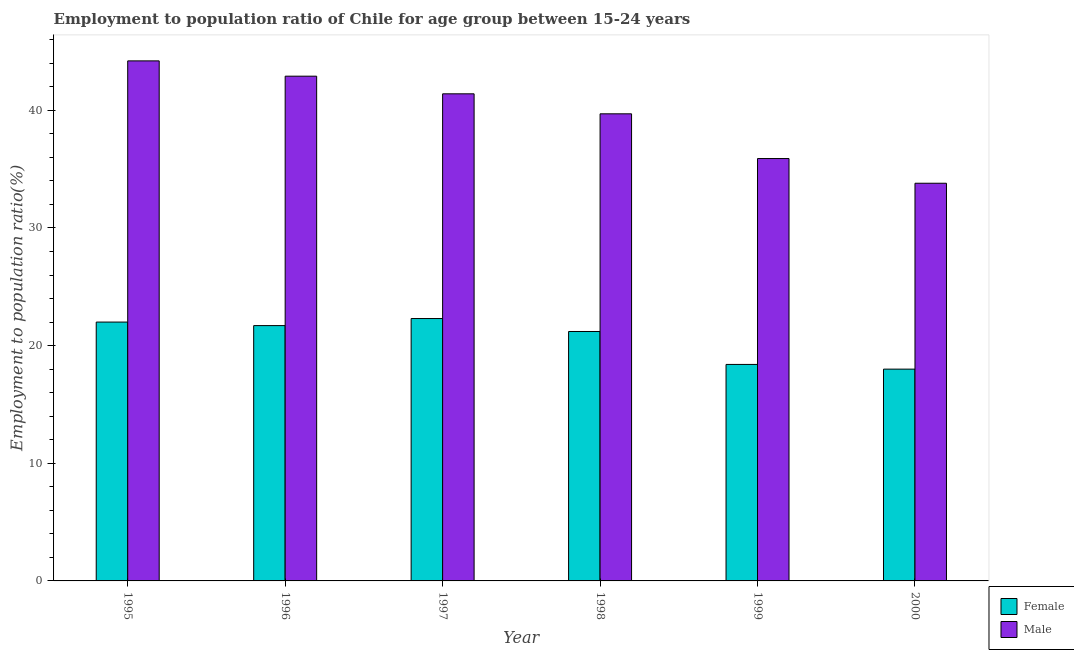How many groups of bars are there?
Provide a succinct answer. 6. How many bars are there on the 3rd tick from the right?
Provide a short and direct response. 2. What is the label of the 6th group of bars from the left?
Your answer should be very brief. 2000. In how many cases, is the number of bars for a given year not equal to the number of legend labels?
Offer a very short reply. 0. What is the employment to population ratio(male) in 1998?
Offer a terse response. 39.7. Across all years, what is the maximum employment to population ratio(female)?
Offer a terse response. 22.3. Across all years, what is the minimum employment to population ratio(male)?
Make the answer very short. 33.8. In which year was the employment to population ratio(female) maximum?
Your answer should be compact. 1997. What is the total employment to population ratio(female) in the graph?
Make the answer very short. 123.6. What is the difference between the employment to population ratio(male) in 1995 and that in 1998?
Give a very brief answer. 4.5. What is the difference between the employment to population ratio(female) in 1995 and the employment to population ratio(male) in 1996?
Ensure brevity in your answer.  0.3. What is the average employment to population ratio(male) per year?
Your answer should be compact. 39.65. What is the ratio of the employment to population ratio(male) in 1995 to that in 1996?
Your response must be concise. 1.03. Is the employment to population ratio(female) in 1996 less than that in 1998?
Offer a very short reply. No. Is the difference between the employment to population ratio(female) in 1995 and 1998 greater than the difference between the employment to population ratio(male) in 1995 and 1998?
Keep it short and to the point. No. What is the difference between the highest and the second highest employment to population ratio(female)?
Provide a short and direct response. 0.3. What is the difference between the highest and the lowest employment to population ratio(male)?
Your response must be concise. 10.4. In how many years, is the employment to population ratio(female) greater than the average employment to population ratio(female) taken over all years?
Your answer should be compact. 4. Is the sum of the employment to population ratio(female) in 1995 and 2000 greater than the maximum employment to population ratio(male) across all years?
Keep it short and to the point. Yes. What does the 1st bar from the right in 2000 represents?
Make the answer very short. Male. Are all the bars in the graph horizontal?
Offer a very short reply. No. How many years are there in the graph?
Your answer should be compact. 6. Are the values on the major ticks of Y-axis written in scientific E-notation?
Ensure brevity in your answer.  No. Does the graph contain any zero values?
Make the answer very short. No. Does the graph contain grids?
Provide a succinct answer. No. Where does the legend appear in the graph?
Ensure brevity in your answer.  Bottom right. How many legend labels are there?
Keep it short and to the point. 2. What is the title of the graph?
Your response must be concise. Employment to population ratio of Chile for age group between 15-24 years. What is the Employment to population ratio(%) in Male in 1995?
Offer a terse response. 44.2. What is the Employment to population ratio(%) of Female in 1996?
Keep it short and to the point. 21.7. What is the Employment to population ratio(%) in Male in 1996?
Make the answer very short. 42.9. What is the Employment to population ratio(%) of Female in 1997?
Give a very brief answer. 22.3. What is the Employment to population ratio(%) of Male in 1997?
Your answer should be compact. 41.4. What is the Employment to population ratio(%) in Female in 1998?
Your answer should be compact. 21.2. What is the Employment to population ratio(%) of Male in 1998?
Offer a very short reply. 39.7. What is the Employment to population ratio(%) of Female in 1999?
Make the answer very short. 18.4. What is the Employment to population ratio(%) in Male in 1999?
Your response must be concise. 35.9. What is the Employment to population ratio(%) in Male in 2000?
Make the answer very short. 33.8. Across all years, what is the maximum Employment to population ratio(%) of Female?
Your response must be concise. 22.3. Across all years, what is the maximum Employment to population ratio(%) of Male?
Your answer should be compact. 44.2. Across all years, what is the minimum Employment to population ratio(%) in Male?
Your answer should be compact. 33.8. What is the total Employment to population ratio(%) of Female in the graph?
Your answer should be compact. 123.6. What is the total Employment to population ratio(%) in Male in the graph?
Make the answer very short. 237.9. What is the difference between the Employment to population ratio(%) in Female in 1995 and that in 1996?
Provide a succinct answer. 0.3. What is the difference between the Employment to population ratio(%) in Male in 1995 and that in 1996?
Ensure brevity in your answer.  1.3. What is the difference between the Employment to population ratio(%) in Female in 1995 and that in 1997?
Give a very brief answer. -0.3. What is the difference between the Employment to population ratio(%) in Female in 1995 and that in 1998?
Keep it short and to the point. 0.8. What is the difference between the Employment to population ratio(%) in Male in 1995 and that in 1998?
Your answer should be compact. 4.5. What is the difference between the Employment to population ratio(%) of Female in 1995 and that in 1999?
Provide a succinct answer. 3.6. What is the difference between the Employment to population ratio(%) in Male in 1995 and that in 1999?
Provide a succinct answer. 8.3. What is the difference between the Employment to population ratio(%) of Female in 1995 and that in 2000?
Your answer should be very brief. 4. What is the difference between the Employment to population ratio(%) in Male in 1995 and that in 2000?
Your answer should be compact. 10.4. What is the difference between the Employment to population ratio(%) in Male in 1996 and that in 1999?
Give a very brief answer. 7. What is the difference between the Employment to population ratio(%) in Female in 1996 and that in 2000?
Ensure brevity in your answer.  3.7. What is the difference between the Employment to population ratio(%) of Female in 1997 and that in 1999?
Your response must be concise. 3.9. What is the difference between the Employment to population ratio(%) of Female in 1998 and that in 2000?
Offer a very short reply. 3.2. What is the difference between the Employment to population ratio(%) of Female in 1999 and that in 2000?
Your response must be concise. 0.4. What is the difference between the Employment to population ratio(%) of Female in 1995 and the Employment to population ratio(%) of Male in 1996?
Keep it short and to the point. -20.9. What is the difference between the Employment to population ratio(%) in Female in 1995 and the Employment to population ratio(%) in Male in 1997?
Offer a very short reply. -19.4. What is the difference between the Employment to population ratio(%) of Female in 1995 and the Employment to population ratio(%) of Male in 1998?
Keep it short and to the point. -17.7. What is the difference between the Employment to population ratio(%) of Female in 1995 and the Employment to population ratio(%) of Male in 2000?
Make the answer very short. -11.8. What is the difference between the Employment to population ratio(%) of Female in 1996 and the Employment to population ratio(%) of Male in 1997?
Keep it short and to the point. -19.7. What is the difference between the Employment to population ratio(%) in Female in 1996 and the Employment to population ratio(%) in Male in 1998?
Offer a terse response. -18. What is the difference between the Employment to population ratio(%) of Female in 1996 and the Employment to population ratio(%) of Male in 2000?
Provide a short and direct response. -12.1. What is the difference between the Employment to population ratio(%) of Female in 1997 and the Employment to population ratio(%) of Male in 1998?
Ensure brevity in your answer.  -17.4. What is the difference between the Employment to population ratio(%) in Female in 1997 and the Employment to population ratio(%) in Male in 1999?
Provide a short and direct response. -13.6. What is the difference between the Employment to population ratio(%) of Female in 1997 and the Employment to population ratio(%) of Male in 2000?
Make the answer very short. -11.5. What is the difference between the Employment to population ratio(%) in Female in 1998 and the Employment to population ratio(%) in Male in 1999?
Provide a short and direct response. -14.7. What is the difference between the Employment to population ratio(%) in Female in 1999 and the Employment to population ratio(%) in Male in 2000?
Your answer should be compact. -15.4. What is the average Employment to population ratio(%) in Female per year?
Ensure brevity in your answer.  20.6. What is the average Employment to population ratio(%) in Male per year?
Ensure brevity in your answer.  39.65. In the year 1995, what is the difference between the Employment to population ratio(%) in Female and Employment to population ratio(%) in Male?
Keep it short and to the point. -22.2. In the year 1996, what is the difference between the Employment to population ratio(%) in Female and Employment to population ratio(%) in Male?
Your answer should be compact. -21.2. In the year 1997, what is the difference between the Employment to population ratio(%) in Female and Employment to population ratio(%) in Male?
Your answer should be compact. -19.1. In the year 1998, what is the difference between the Employment to population ratio(%) of Female and Employment to population ratio(%) of Male?
Provide a succinct answer. -18.5. In the year 1999, what is the difference between the Employment to population ratio(%) of Female and Employment to population ratio(%) of Male?
Your answer should be compact. -17.5. In the year 2000, what is the difference between the Employment to population ratio(%) of Female and Employment to population ratio(%) of Male?
Offer a very short reply. -15.8. What is the ratio of the Employment to population ratio(%) in Female in 1995 to that in 1996?
Make the answer very short. 1.01. What is the ratio of the Employment to population ratio(%) in Male in 1995 to that in 1996?
Ensure brevity in your answer.  1.03. What is the ratio of the Employment to population ratio(%) in Female in 1995 to that in 1997?
Keep it short and to the point. 0.99. What is the ratio of the Employment to population ratio(%) in Male in 1995 to that in 1997?
Make the answer very short. 1.07. What is the ratio of the Employment to population ratio(%) of Female in 1995 to that in 1998?
Provide a short and direct response. 1.04. What is the ratio of the Employment to population ratio(%) of Male in 1995 to that in 1998?
Offer a very short reply. 1.11. What is the ratio of the Employment to population ratio(%) in Female in 1995 to that in 1999?
Keep it short and to the point. 1.2. What is the ratio of the Employment to population ratio(%) in Male in 1995 to that in 1999?
Make the answer very short. 1.23. What is the ratio of the Employment to population ratio(%) of Female in 1995 to that in 2000?
Make the answer very short. 1.22. What is the ratio of the Employment to population ratio(%) in Male in 1995 to that in 2000?
Your answer should be very brief. 1.31. What is the ratio of the Employment to population ratio(%) in Female in 1996 to that in 1997?
Your response must be concise. 0.97. What is the ratio of the Employment to population ratio(%) in Male in 1996 to that in 1997?
Your answer should be very brief. 1.04. What is the ratio of the Employment to population ratio(%) in Female in 1996 to that in 1998?
Keep it short and to the point. 1.02. What is the ratio of the Employment to population ratio(%) in Male in 1996 to that in 1998?
Your response must be concise. 1.08. What is the ratio of the Employment to population ratio(%) in Female in 1996 to that in 1999?
Your response must be concise. 1.18. What is the ratio of the Employment to population ratio(%) in Male in 1996 to that in 1999?
Offer a very short reply. 1.2. What is the ratio of the Employment to population ratio(%) in Female in 1996 to that in 2000?
Offer a very short reply. 1.21. What is the ratio of the Employment to population ratio(%) of Male in 1996 to that in 2000?
Make the answer very short. 1.27. What is the ratio of the Employment to population ratio(%) in Female in 1997 to that in 1998?
Provide a succinct answer. 1.05. What is the ratio of the Employment to population ratio(%) of Male in 1997 to that in 1998?
Ensure brevity in your answer.  1.04. What is the ratio of the Employment to population ratio(%) in Female in 1997 to that in 1999?
Ensure brevity in your answer.  1.21. What is the ratio of the Employment to population ratio(%) of Male in 1997 to that in 1999?
Offer a very short reply. 1.15. What is the ratio of the Employment to population ratio(%) of Female in 1997 to that in 2000?
Give a very brief answer. 1.24. What is the ratio of the Employment to population ratio(%) of Male in 1997 to that in 2000?
Make the answer very short. 1.22. What is the ratio of the Employment to population ratio(%) of Female in 1998 to that in 1999?
Your response must be concise. 1.15. What is the ratio of the Employment to population ratio(%) of Male in 1998 to that in 1999?
Offer a terse response. 1.11. What is the ratio of the Employment to population ratio(%) in Female in 1998 to that in 2000?
Keep it short and to the point. 1.18. What is the ratio of the Employment to population ratio(%) in Male in 1998 to that in 2000?
Your answer should be very brief. 1.17. What is the ratio of the Employment to population ratio(%) in Female in 1999 to that in 2000?
Offer a very short reply. 1.02. What is the ratio of the Employment to population ratio(%) of Male in 1999 to that in 2000?
Provide a short and direct response. 1.06. 